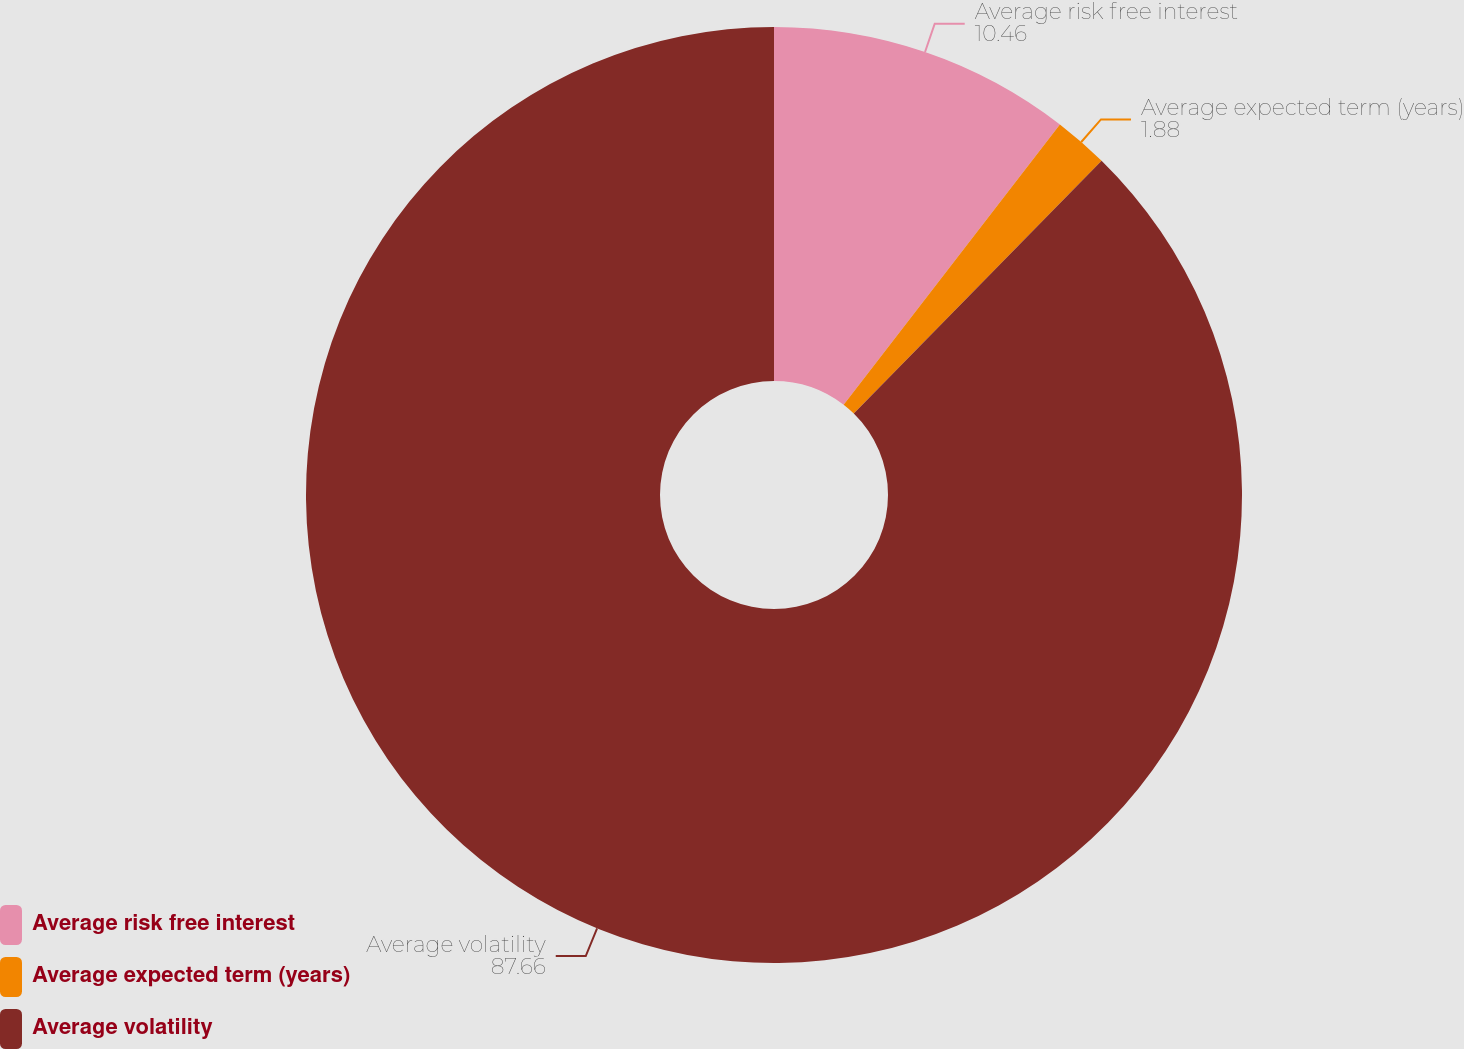<chart> <loc_0><loc_0><loc_500><loc_500><pie_chart><fcel>Average risk free interest<fcel>Average expected term (years)<fcel>Average volatility<nl><fcel>10.46%<fcel>1.88%<fcel>87.66%<nl></chart> 